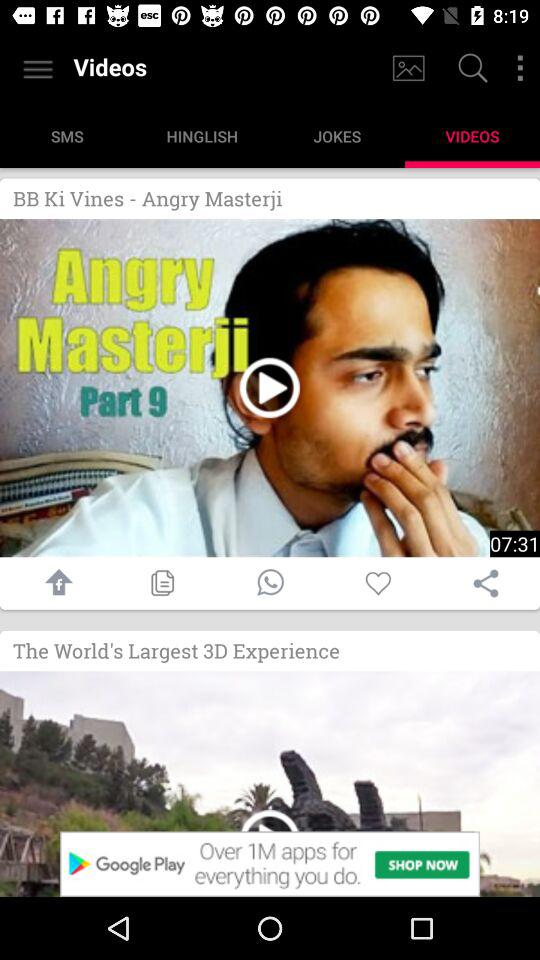What is the name of the video? The videos are "BB Ki Vines-Angry Masterji" and "The World's Largest 3D Experience". 